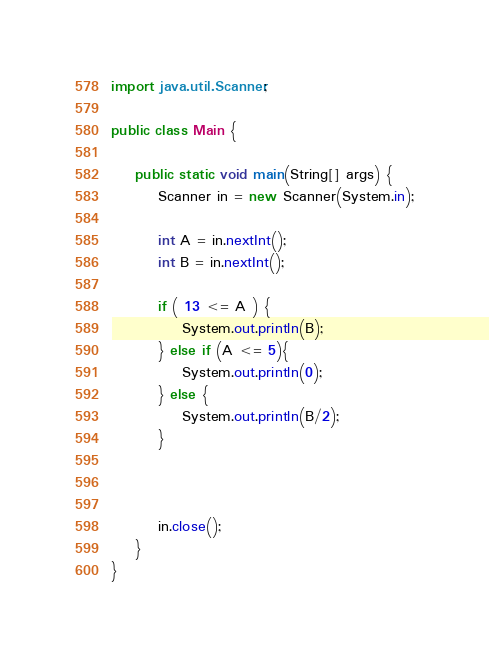<code> <loc_0><loc_0><loc_500><loc_500><_Java_>import java.util.Scanner;

public class Main {

	public static void main(String[] args) {
		Scanner in = new Scanner(System.in);
		
		int A = in.nextInt();
		int B = in.nextInt();
		
		if ( 13 <= A ) {
			System.out.println(B);
		} else if (A <= 5){
			System.out.println(0);
		} else {
			System.out.println(B/2);
		}

		

		in.close();
	}
}</code> 